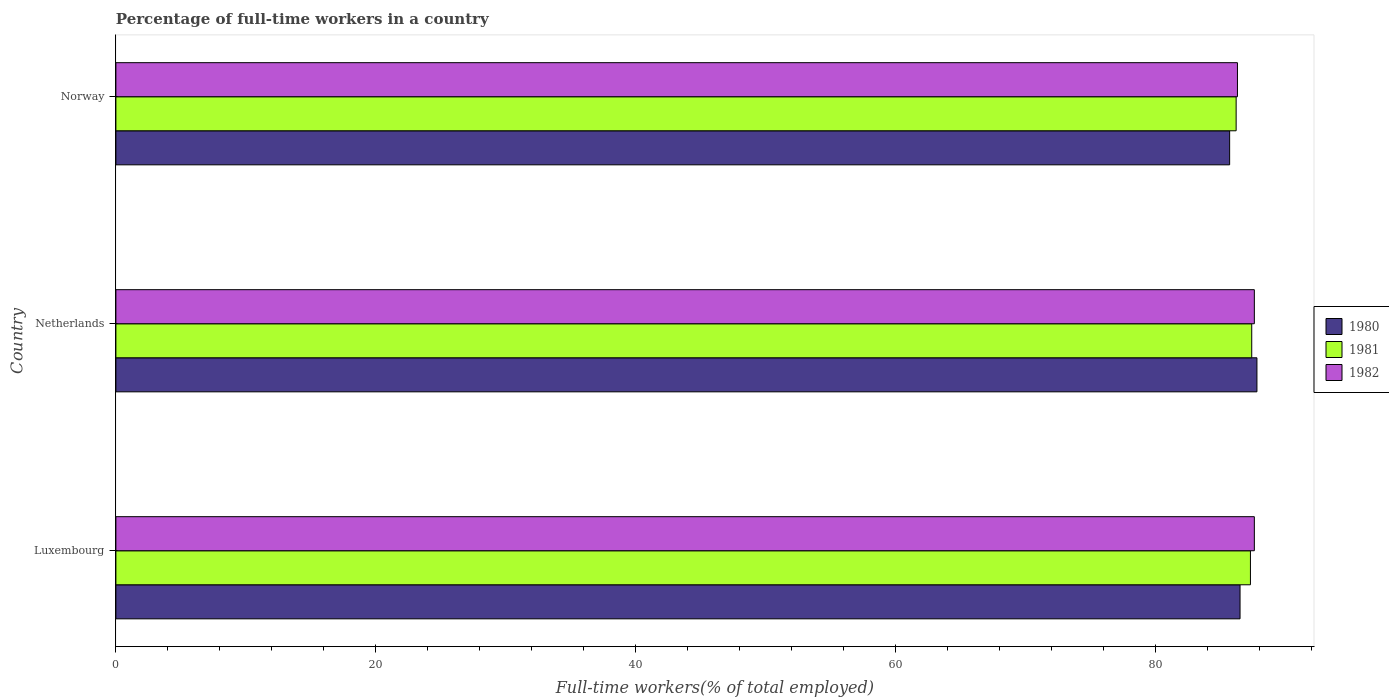Are the number of bars per tick equal to the number of legend labels?
Offer a terse response. Yes. How many bars are there on the 2nd tick from the top?
Your answer should be very brief. 3. What is the label of the 3rd group of bars from the top?
Ensure brevity in your answer.  Luxembourg. In how many cases, is the number of bars for a given country not equal to the number of legend labels?
Give a very brief answer. 0. What is the percentage of full-time workers in 1982 in Luxembourg?
Provide a short and direct response. 87.6. Across all countries, what is the maximum percentage of full-time workers in 1982?
Offer a terse response. 87.6. Across all countries, what is the minimum percentage of full-time workers in 1982?
Keep it short and to the point. 86.3. In which country was the percentage of full-time workers in 1981 maximum?
Offer a very short reply. Netherlands. In which country was the percentage of full-time workers in 1981 minimum?
Your response must be concise. Norway. What is the total percentage of full-time workers in 1982 in the graph?
Make the answer very short. 261.5. What is the difference between the percentage of full-time workers in 1980 in Netherlands and that in Norway?
Keep it short and to the point. 2.1. What is the difference between the percentage of full-time workers in 1980 in Netherlands and the percentage of full-time workers in 1981 in Luxembourg?
Your answer should be compact. 0.5. What is the average percentage of full-time workers in 1982 per country?
Keep it short and to the point. 87.17. What is the difference between the percentage of full-time workers in 1982 and percentage of full-time workers in 1981 in Norway?
Your answer should be compact. 0.1. What is the ratio of the percentage of full-time workers in 1981 in Netherlands to that in Norway?
Provide a succinct answer. 1.01. Is the difference between the percentage of full-time workers in 1982 in Netherlands and Norway greater than the difference between the percentage of full-time workers in 1981 in Netherlands and Norway?
Provide a short and direct response. Yes. What is the difference between the highest and the second highest percentage of full-time workers in 1982?
Provide a short and direct response. 0. What is the difference between the highest and the lowest percentage of full-time workers in 1980?
Keep it short and to the point. 2.1. What does the 3rd bar from the top in Luxembourg represents?
Make the answer very short. 1980. What does the 2nd bar from the bottom in Norway represents?
Offer a terse response. 1981. How many bars are there?
Provide a succinct answer. 9. What is the title of the graph?
Provide a short and direct response. Percentage of full-time workers in a country. What is the label or title of the X-axis?
Keep it short and to the point. Full-time workers(% of total employed). What is the Full-time workers(% of total employed) in 1980 in Luxembourg?
Offer a very short reply. 86.5. What is the Full-time workers(% of total employed) in 1981 in Luxembourg?
Your response must be concise. 87.3. What is the Full-time workers(% of total employed) of 1982 in Luxembourg?
Your response must be concise. 87.6. What is the Full-time workers(% of total employed) in 1980 in Netherlands?
Your answer should be very brief. 87.8. What is the Full-time workers(% of total employed) of 1981 in Netherlands?
Ensure brevity in your answer.  87.4. What is the Full-time workers(% of total employed) of 1982 in Netherlands?
Your answer should be very brief. 87.6. What is the Full-time workers(% of total employed) in 1980 in Norway?
Provide a succinct answer. 85.7. What is the Full-time workers(% of total employed) of 1981 in Norway?
Your response must be concise. 86.2. What is the Full-time workers(% of total employed) of 1982 in Norway?
Provide a succinct answer. 86.3. Across all countries, what is the maximum Full-time workers(% of total employed) of 1980?
Give a very brief answer. 87.8. Across all countries, what is the maximum Full-time workers(% of total employed) in 1981?
Ensure brevity in your answer.  87.4. Across all countries, what is the maximum Full-time workers(% of total employed) of 1982?
Your response must be concise. 87.6. Across all countries, what is the minimum Full-time workers(% of total employed) in 1980?
Your response must be concise. 85.7. Across all countries, what is the minimum Full-time workers(% of total employed) of 1981?
Provide a short and direct response. 86.2. Across all countries, what is the minimum Full-time workers(% of total employed) in 1982?
Offer a terse response. 86.3. What is the total Full-time workers(% of total employed) of 1980 in the graph?
Offer a very short reply. 260. What is the total Full-time workers(% of total employed) of 1981 in the graph?
Provide a succinct answer. 260.9. What is the total Full-time workers(% of total employed) of 1982 in the graph?
Provide a succinct answer. 261.5. What is the difference between the Full-time workers(% of total employed) in 1980 in Luxembourg and that in Netherlands?
Ensure brevity in your answer.  -1.3. What is the difference between the Full-time workers(% of total employed) of 1981 in Luxembourg and that in Netherlands?
Your answer should be very brief. -0.1. What is the difference between the Full-time workers(% of total employed) in 1980 in Luxembourg and that in Norway?
Provide a succinct answer. 0.8. What is the difference between the Full-time workers(% of total employed) of 1981 in Netherlands and that in Norway?
Keep it short and to the point. 1.2. What is the difference between the Full-time workers(% of total employed) in 1982 in Netherlands and that in Norway?
Your answer should be very brief. 1.3. What is the difference between the Full-time workers(% of total employed) in 1980 in Luxembourg and the Full-time workers(% of total employed) in 1981 in Netherlands?
Your response must be concise. -0.9. What is the difference between the Full-time workers(% of total employed) of 1980 in Luxembourg and the Full-time workers(% of total employed) of 1982 in Netherlands?
Provide a succinct answer. -1.1. What is the difference between the Full-time workers(% of total employed) of 1981 in Luxembourg and the Full-time workers(% of total employed) of 1982 in Netherlands?
Provide a succinct answer. -0.3. What is the difference between the Full-time workers(% of total employed) in 1980 in Luxembourg and the Full-time workers(% of total employed) in 1982 in Norway?
Provide a short and direct response. 0.2. What is the difference between the Full-time workers(% of total employed) in 1981 in Luxembourg and the Full-time workers(% of total employed) in 1982 in Norway?
Offer a terse response. 1. What is the difference between the Full-time workers(% of total employed) in 1980 in Netherlands and the Full-time workers(% of total employed) in 1982 in Norway?
Your answer should be very brief. 1.5. What is the difference between the Full-time workers(% of total employed) of 1981 in Netherlands and the Full-time workers(% of total employed) of 1982 in Norway?
Make the answer very short. 1.1. What is the average Full-time workers(% of total employed) in 1980 per country?
Give a very brief answer. 86.67. What is the average Full-time workers(% of total employed) in 1981 per country?
Your response must be concise. 86.97. What is the average Full-time workers(% of total employed) of 1982 per country?
Offer a terse response. 87.17. What is the difference between the Full-time workers(% of total employed) of 1980 and Full-time workers(% of total employed) of 1982 in Luxembourg?
Offer a terse response. -1.1. What is the difference between the Full-time workers(% of total employed) of 1980 and Full-time workers(% of total employed) of 1981 in Norway?
Keep it short and to the point. -0.5. What is the difference between the Full-time workers(% of total employed) in 1981 and Full-time workers(% of total employed) in 1982 in Norway?
Provide a short and direct response. -0.1. What is the ratio of the Full-time workers(% of total employed) in 1980 in Luxembourg to that in Netherlands?
Offer a very short reply. 0.99. What is the ratio of the Full-time workers(% of total employed) in 1980 in Luxembourg to that in Norway?
Keep it short and to the point. 1.01. What is the ratio of the Full-time workers(% of total employed) of 1981 in Luxembourg to that in Norway?
Ensure brevity in your answer.  1.01. What is the ratio of the Full-time workers(% of total employed) of 1982 in Luxembourg to that in Norway?
Give a very brief answer. 1.02. What is the ratio of the Full-time workers(% of total employed) of 1980 in Netherlands to that in Norway?
Provide a short and direct response. 1.02. What is the ratio of the Full-time workers(% of total employed) in 1981 in Netherlands to that in Norway?
Offer a terse response. 1.01. What is the ratio of the Full-time workers(% of total employed) in 1982 in Netherlands to that in Norway?
Provide a short and direct response. 1.02. What is the difference between the highest and the second highest Full-time workers(% of total employed) of 1982?
Your answer should be very brief. 0. What is the difference between the highest and the lowest Full-time workers(% of total employed) of 1981?
Ensure brevity in your answer.  1.2. 